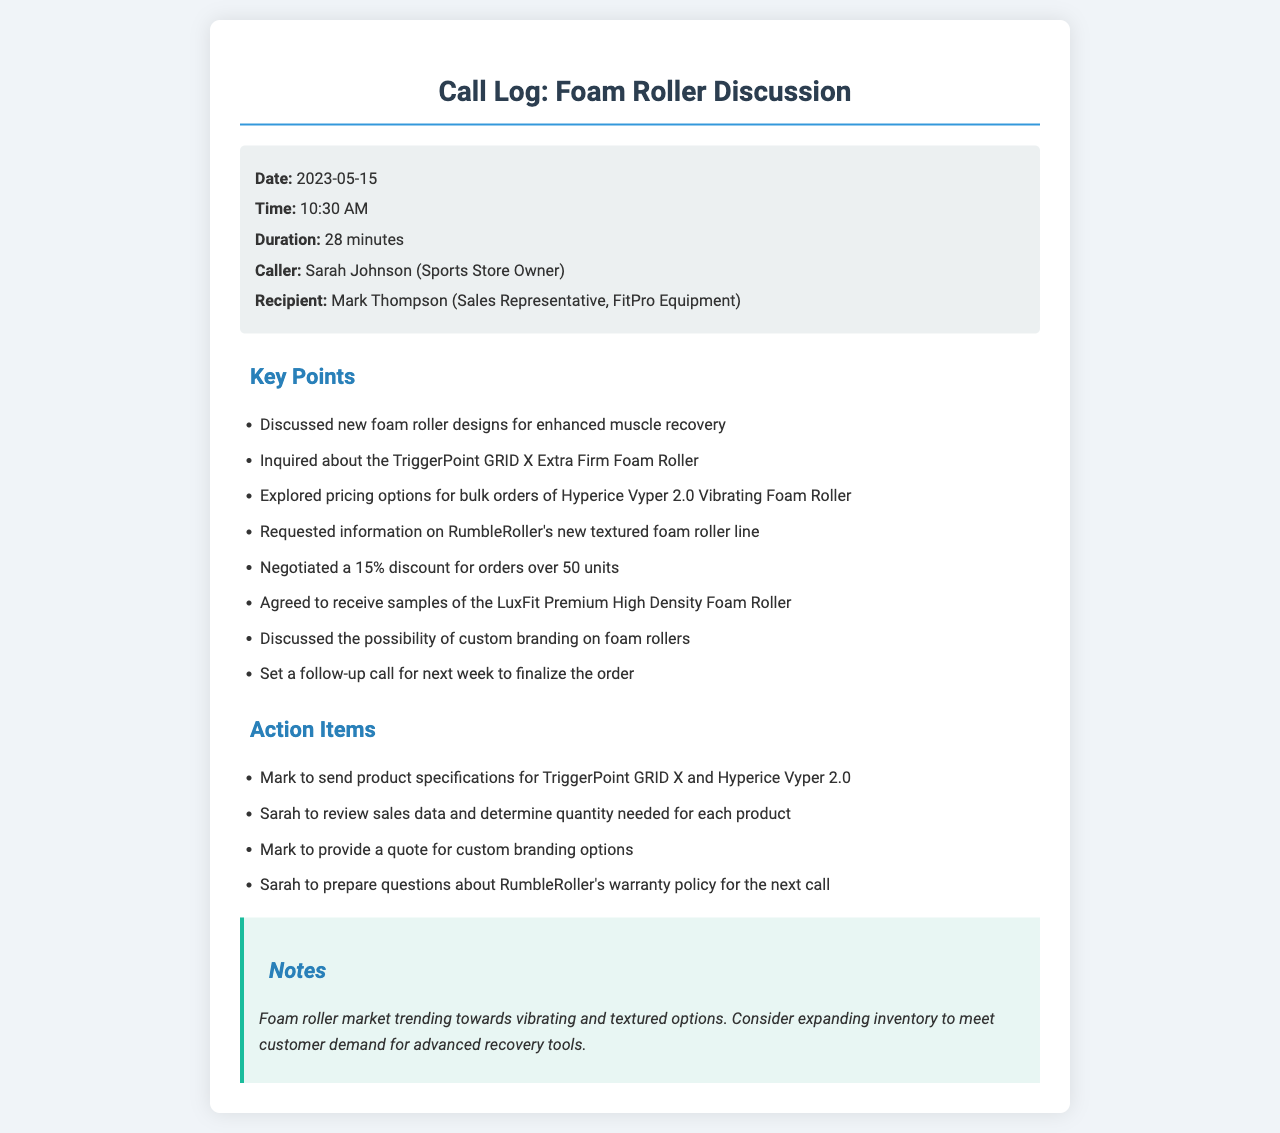what is the date of the call? The date of the call is clearly stated in the document as May 15, 2023.
Answer: May 15, 2023 who called during the conversation? The caller is identified in the call details section as Sarah Johnson, who is the Sports Store Owner.
Answer: Sarah Johnson who was the recipient of the call? The recipient of the call is provided in the call details as Mark Thompson, who is a Sales Representative at FitPro Equipment.
Answer: Mark Thompson how long did the call last? The duration of the call is mentioned in the call details as 28 minutes.
Answer: 28 minutes what product was inquired about specifically? The document specifies that the TriggerPoint GRID X Extra Firm Foam Roller was inquired about during the call.
Answer: TriggerPoint GRID X Extra Firm Foam Roller what discount was negotiated? The terms of the negotiation include a 15% discount for orders over 50 units, which is clearly stated in the key points.
Answer: 15% what is an action item for Mark? One action item detailed for Mark is to send product specifications for TriggerPoint GRID X and Hyperice Vyper 2.0.
Answer: Send product specifications what was discussed regarding custom branding? During the call, the possibility of custom branding on foam rollers was discussed, as mentioned in the key points.
Answer: Custom branding when is the follow-up call scheduled? The follow-up call was set for next week, indicating when further discussions will take place.
Answer: Next week 